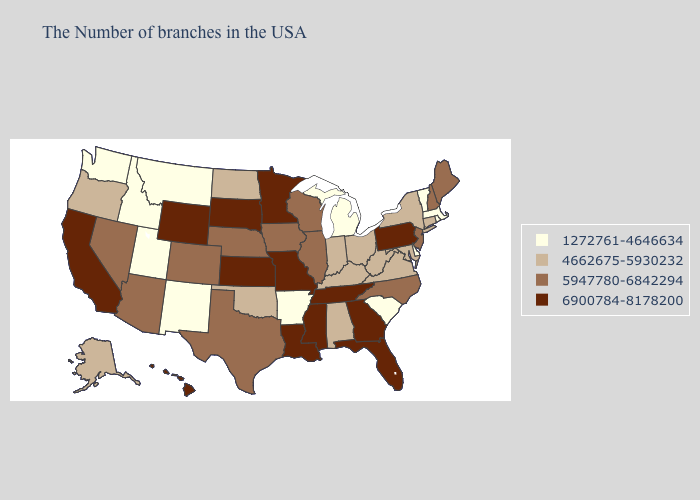Which states have the lowest value in the USA?
Keep it brief. Massachusetts, Rhode Island, Vermont, Delaware, South Carolina, Michigan, Arkansas, New Mexico, Utah, Montana, Idaho, Washington. What is the highest value in the South ?
Keep it brief. 6900784-8178200. Does the first symbol in the legend represent the smallest category?
Keep it brief. Yes. Does Maine have the highest value in the USA?
Be succinct. No. Does Arkansas have the same value as South Carolina?
Keep it brief. Yes. Name the states that have a value in the range 5947780-6842294?
Give a very brief answer. Maine, New Hampshire, New Jersey, North Carolina, Wisconsin, Illinois, Iowa, Nebraska, Texas, Colorado, Arizona, Nevada. What is the value of Idaho?
Write a very short answer. 1272761-4646634. Among the states that border New Mexico , does Arizona have the highest value?
Be succinct. Yes. Which states have the highest value in the USA?
Answer briefly. Pennsylvania, Florida, Georgia, Tennessee, Mississippi, Louisiana, Missouri, Minnesota, Kansas, South Dakota, Wyoming, California, Hawaii. What is the highest value in the USA?
Be succinct. 6900784-8178200. Name the states that have a value in the range 6900784-8178200?
Be succinct. Pennsylvania, Florida, Georgia, Tennessee, Mississippi, Louisiana, Missouri, Minnesota, Kansas, South Dakota, Wyoming, California, Hawaii. Name the states that have a value in the range 4662675-5930232?
Keep it brief. Connecticut, New York, Maryland, Virginia, West Virginia, Ohio, Kentucky, Indiana, Alabama, Oklahoma, North Dakota, Oregon, Alaska. Does Tennessee have the same value as South Carolina?
Short answer required. No. What is the value of North Dakota?
Answer briefly. 4662675-5930232. Name the states that have a value in the range 1272761-4646634?
Quick response, please. Massachusetts, Rhode Island, Vermont, Delaware, South Carolina, Michigan, Arkansas, New Mexico, Utah, Montana, Idaho, Washington. 